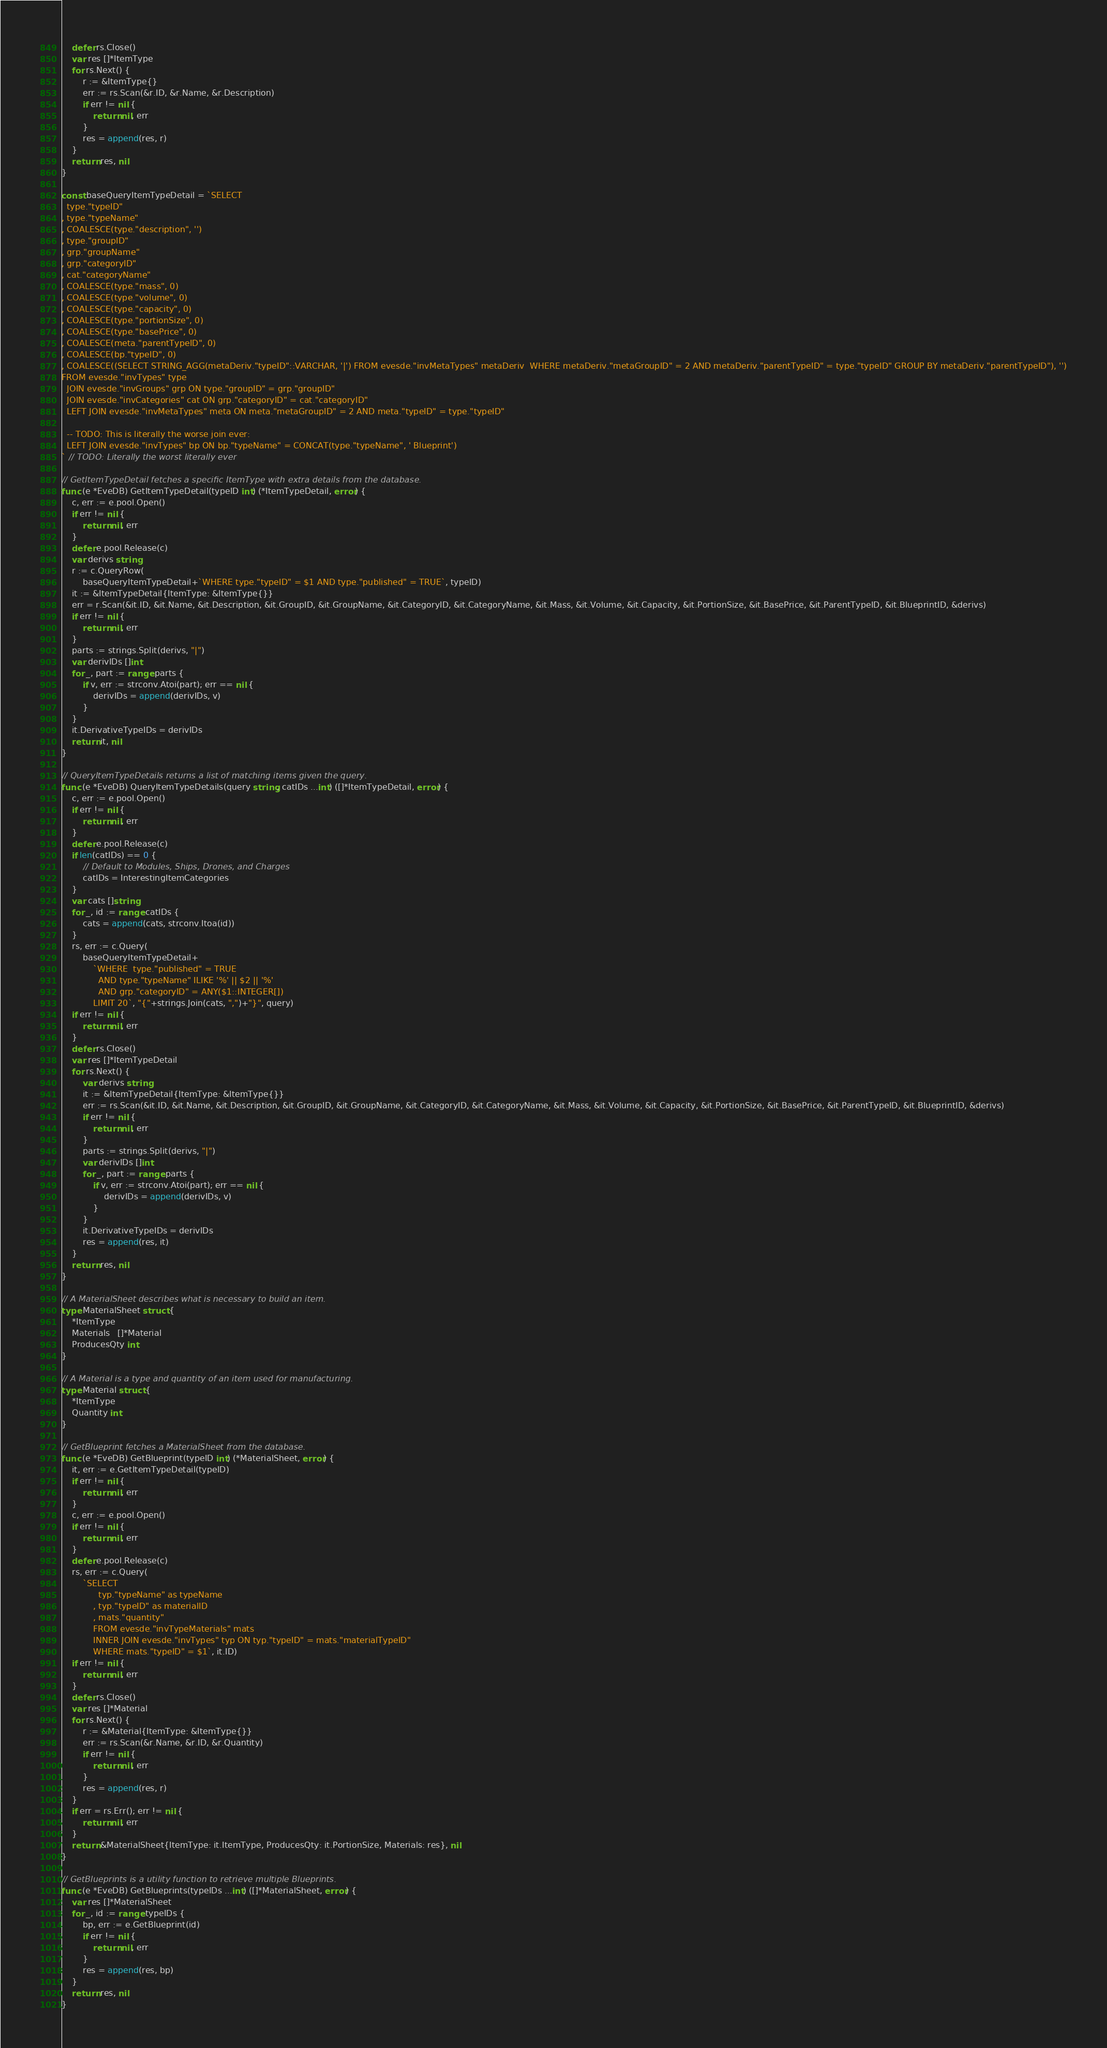Convert code to text. <code><loc_0><loc_0><loc_500><loc_500><_Go_>	defer rs.Close()
	var res []*ItemType
	for rs.Next() {
		r := &ItemType{}
		err := rs.Scan(&r.ID, &r.Name, &r.Description)
		if err != nil {
			return nil, err
		}
		res = append(res, r)
	}
	return res, nil
}

const baseQueryItemTypeDetail = `SELECT
  type."typeID"
, type."typeName"
, COALESCE(type."description", '')
, type."groupID"
, grp."groupName"
, grp."categoryID"
, cat."categoryName"
, COALESCE(type."mass", 0)
, COALESCE(type."volume", 0)
, COALESCE(type."capacity", 0)
, COALESCE(type."portionSize", 0)
, COALESCE(type."basePrice", 0)
, COALESCE(meta."parentTypeID", 0)
, COALESCE(bp."typeID", 0)
, COALESCE((SELECT STRING_AGG(metaDeriv."typeID"::VARCHAR, '|') FROM evesde."invMetaTypes" metaDeriv  WHERE metaDeriv."metaGroupID" = 2 AND metaDeriv."parentTypeID" = type."typeID" GROUP BY metaDeriv."parentTypeID"), '')
FROM evesde."invTypes" type
  JOIN evesde."invGroups" grp ON type."groupID" = grp."groupID"
  JOIN evesde."invCategories" cat ON grp."categoryID" = cat."categoryID"
  LEFT JOIN evesde."invMetaTypes" meta ON meta."metaGroupID" = 2 AND meta."typeID" = type."typeID"

  -- TODO: This is literally the worse join ever:
  LEFT JOIN evesde."invTypes" bp ON bp."typeName" = CONCAT(type."typeName", ' Blueprint')
` // TODO: Literally the worst literally ever

// GetItemTypeDetail fetches a specific ItemType with extra details from the database.
func (e *EveDB) GetItemTypeDetail(typeID int) (*ItemTypeDetail, error) {
	c, err := e.pool.Open()
	if err != nil {
		return nil, err
	}
	defer e.pool.Release(c)
	var derivs string
	r := c.QueryRow(
		baseQueryItemTypeDetail+`WHERE type."typeID" = $1 AND type."published" = TRUE`, typeID)
	it := &ItemTypeDetail{ItemType: &ItemType{}}
	err = r.Scan(&it.ID, &it.Name, &it.Description, &it.GroupID, &it.GroupName, &it.CategoryID, &it.CategoryName, &it.Mass, &it.Volume, &it.Capacity, &it.PortionSize, &it.BasePrice, &it.ParentTypeID, &it.BlueprintID, &derivs)
	if err != nil {
		return nil, err
	}
	parts := strings.Split(derivs, "|")
	var derivIDs []int
	for _, part := range parts {
		if v, err := strconv.Atoi(part); err == nil {
			derivIDs = append(derivIDs, v)
		}
	}
	it.DerivativeTypeIDs = derivIDs
	return it, nil
}

// QueryItemTypeDetails returns a list of matching items given the query.
func (e *EveDB) QueryItemTypeDetails(query string, catIDs ...int) ([]*ItemTypeDetail, error) {
	c, err := e.pool.Open()
	if err != nil {
		return nil, err
	}
	defer e.pool.Release(c)
	if len(catIDs) == 0 {
		// Default to Modules, Ships, Drones, and Charges
		catIDs = InterestingItemCategories
	}
	var cats []string
	for _, id := range catIDs {
		cats = append(cats, strconv.Itoa(id))
	}
	rs, err := c.Query(
		baseQueryItemTypeDetail+
			`WHERE  type."published" = TRUE
			  AND type."typeName" ILIKE '%' || $2 || '%'
			  AND grp."categoryID" = ANY($1::INTEGER[])
			LIMIT 20`, "{"+strings.Join(cats, ",")+"}", query)
	if err != nil {
		return nil, err
	}
	defer rs.Close()
	var res []*ItemTypeDetail
	for rs.Next() {
		var derivs string
		it := &ItemTypeDetail{ItemType: &ItemType{}}
		err := rs.Scan(&it.ID, &it.Name, &it.Description, &it.GroupID, &it.GroupName, &it.CategoryID, &it.CategoryName, &it.Mass, &it.Volume, &it.Capacity, &it.PortionSize, &it.BasePrice, &it.ParentTypeID, &it.BlueprintID, &derivs)
		if err != nil {
			return nil, err
		}
		parts := strings.Split(derivs, "|")
		var derivIDs []int
		for _, part := range parts {
			if v, err := strconv.Atoi(part); err == nil {
				derivIDs = append(derivIDs, v)
			}
		}
		it.DerivativeTypeIDs = derivIDs
		res = append(res, it)
	}
	return res, nil
}

// A MaterialSheet describes what is necessary to build an item.
type MaterialSheet struct {
	*ItemType
	Materials   []*Material
	ProducesQty int
}

// A Material is a type and quantity of an item used for manufacturing.
type Material struct {
	*ItemType
	Quantity int
}

// GetBlueprint fetches a MaterialSheet from the database.
func (e *EveDB) GetBlueprint(typeID int) (*MaterialSheet, error) {
	it, err := e.GetItemTypeDetail(typeID)
	if err != nil {
		return nil, err
	}
	c, err := e.pool.Open()
	if err != nil {
		return nil, err
	}
	defer e.pool.Release(c)
	rs, err := c.Query(
		`SELECT
			  typ."typeName" as typeName
			, typ."typeID" as materialID
			, mats."quantity"
			FROM evesde."invTypeMaterials" mats
			INNER JOIN evesde."invTypes" typ ON typ."typeID" = mats."materialTypeID"
			WHERE mats."typeID" = $1`, it.ID)
	if err != nil {
		return nil, err
	}
	defer rs.Close()
	var res []*Material
	for rs.Next() {
		r := &Material{ItemType: &ItemType{}}
		err := rs.Scan(&r.Name, &r.ID, &r.Quantity)
		if err != nil {
			return nil, err
		}
		res = append(res, r)
	}
	if err = rs.Err(); err != nil {
		return nil, err
	}
	return &MaterialSheet{ItemType: it.ItemType, ProducesQty: it.PortionSize, Materials: res}, nil
}

// GetBlueprints is a utility function to retrieve multiple Blueprints.
func (e *EveDB) GetBlueprints(typeIDs ...int) ([]*MaterialSheet, error) {
	var res []*MaterialSheet
	for _, id := range typeIDs {
		bp, err := e.GetBlueprint(id)
		if err != nil {
			return nil, err
		}
		res = append(res, bp)
	}
	return res, nil
}
</code> 